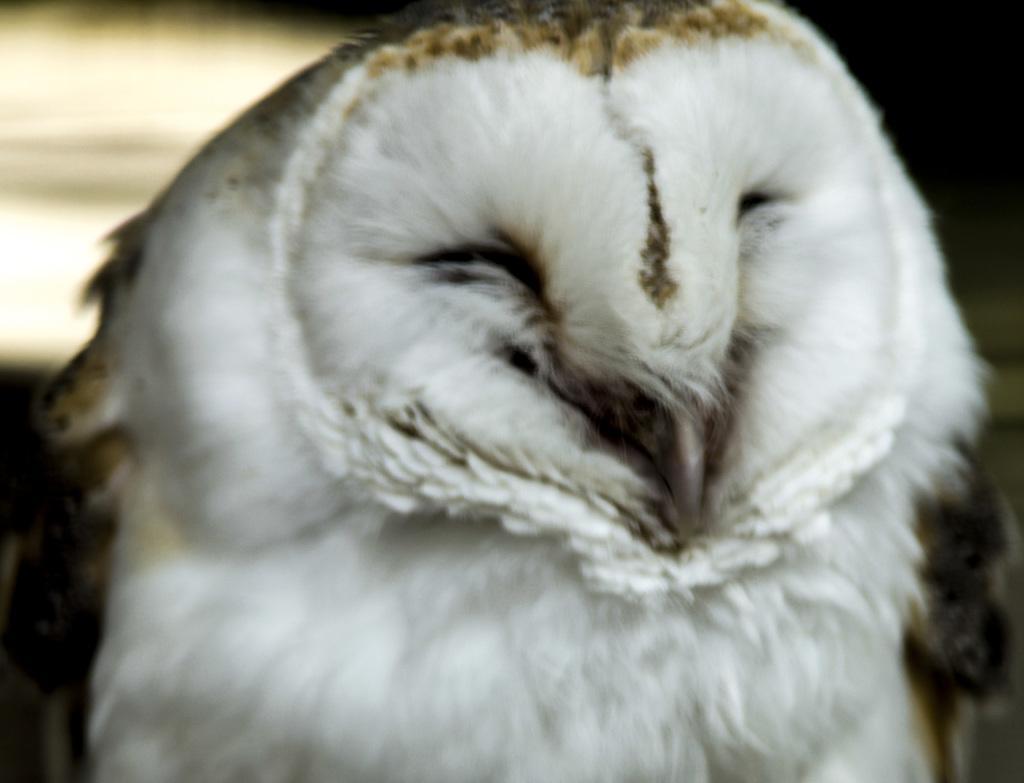Could you give a brief overview of what you see in this image? In the image we can see a bird. Background of the image is blur. 